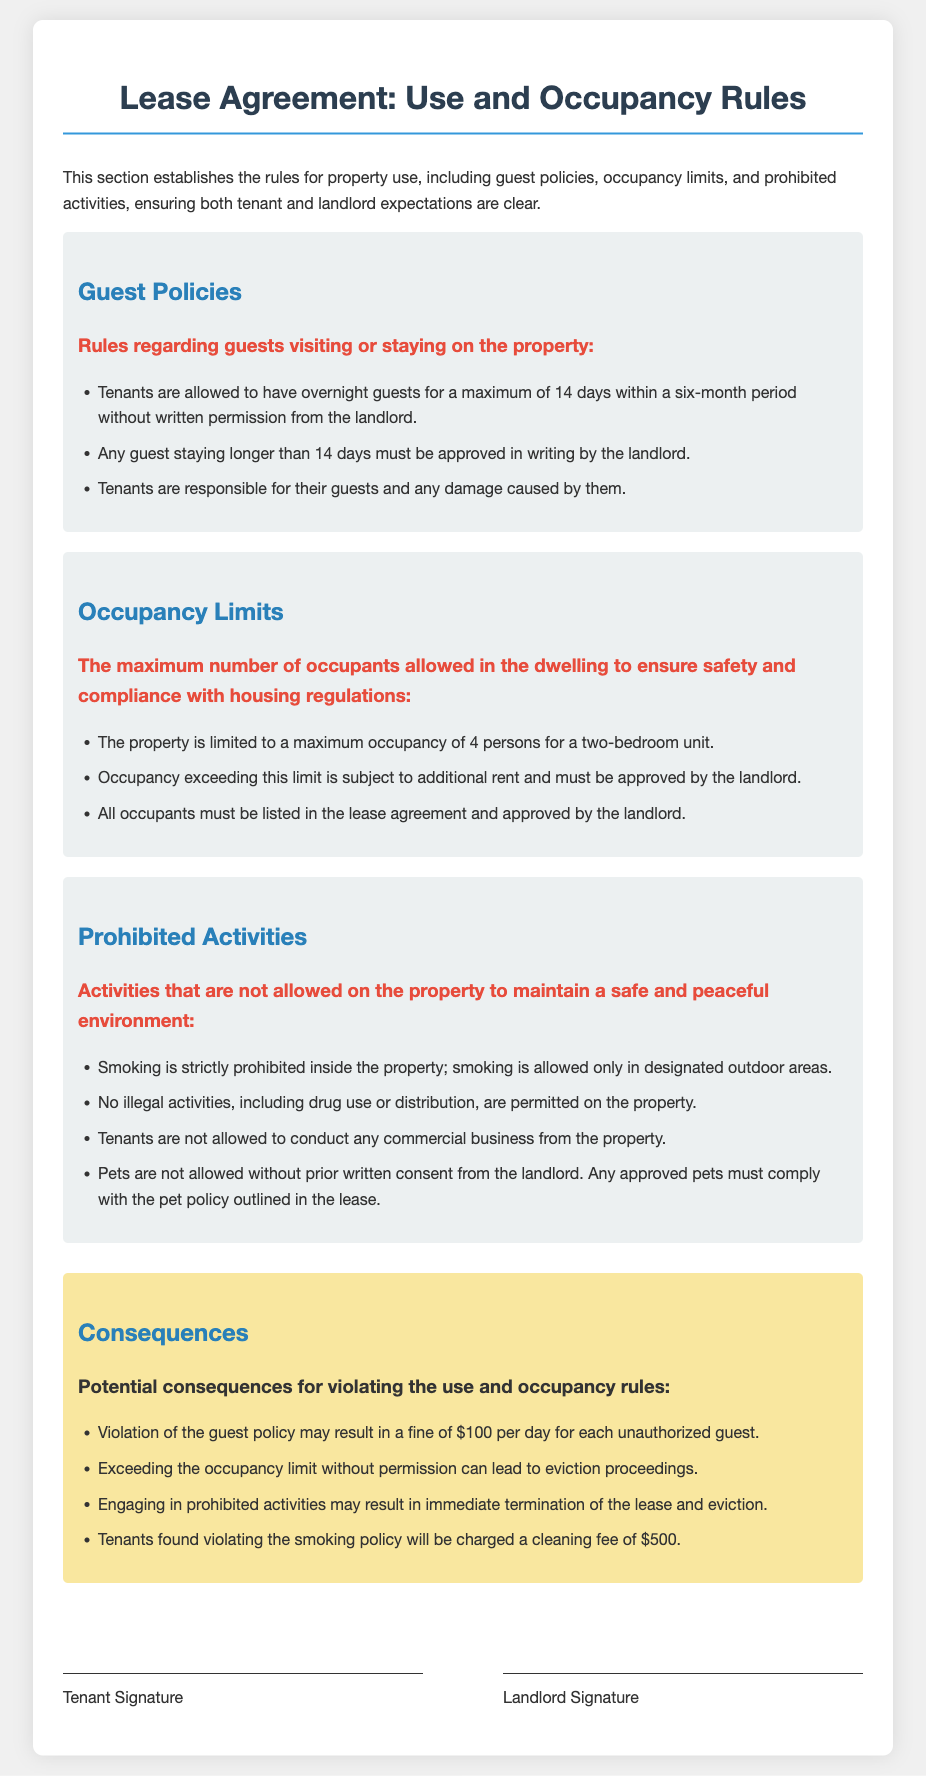What is the maximum number of overnight guests allowed without written permission? The document states that tenants are allowed to have overnight guests for a maximum of 14 days within a six-month period without written permission from the landlord.
Answer: 14 days How many persons are allowed as a maximum occupancy for a two-bedroom unit? The occupancy limits section specifies that the property is limited to a maximum occupancy of 4 persons for a two-bedroom unit.
Answer: 4 persons What is the fine for each unauthorized guest? According to the consequences section, violation of the guest policy may result in a fine of $100 per day for each unauthorized guest.
Answer: $100 Is smoking allowed inside the property? The prohibited activities section clearly states that smoking is strictly prohibited inside the property.
Answer: No What must tenants do if they want to exceed the occupancy limit? The document indicates that occupancy exceeding this limit is subject to additional rent and must be approved by the landlord.
Answer: Approved by the landlord What happens if a tenant is found violating the smoking policy? The consequences section notes that tenants found violating the smoking policy will be charged a cleaning fee of $500.
Answer: $500 What type of activities are tenants not allowed to conduct from the property? The prohibited activities section specifies that tenants are not allowed to conduct any commercial business from the property.
Answer: Commercial business How long can a guest stay without landlord approval? The guest policies state that any guest staying longer than 14 days must be approved in writing by the landlord.
Answer: 14 days What is required for pets to be allowed on the property? The prohibited activities section mentions that pets are not allowed without prior written consent from the landlord.
Answer: Written consent from the landlord 